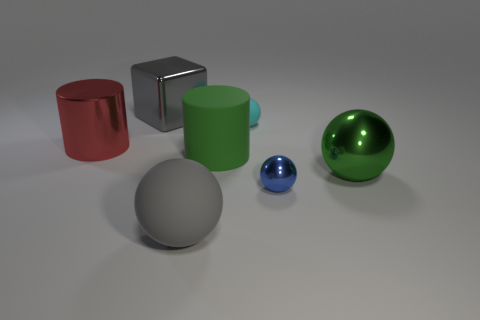Subtract all large metallic balls. How many balls are left? 3 Subtract all gray spheres. How many spheres are left? 3 Add 2 big rubber objects. How many objects exist? 9 Subtract all brown balls. Subtract all cyan cylinders. How many balls are left? 4 Subtract all spheres. How many objects are left? 3 Add 2 green metallic objects. How many green metallic objects are left? 3 Add 7 red objects. How many red objects exist? 8 Subtract 0 blue cylinders. How many objects are left? 7 Subtract all tiny cyan matte balls. Subtract all big gray metallic things. How many objects are left? 5 